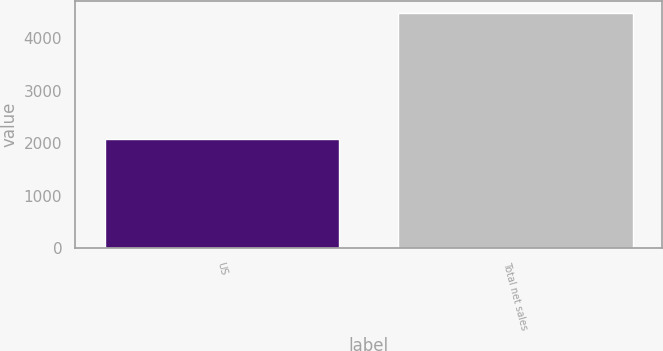Convert chart. <chart><loc_0><loc_0><loc_500><loc_500><bar_chart><fcel>US<fcel>Total net sales<nl><fcel>2081.6<fcel>4490.1<nl></chart> 